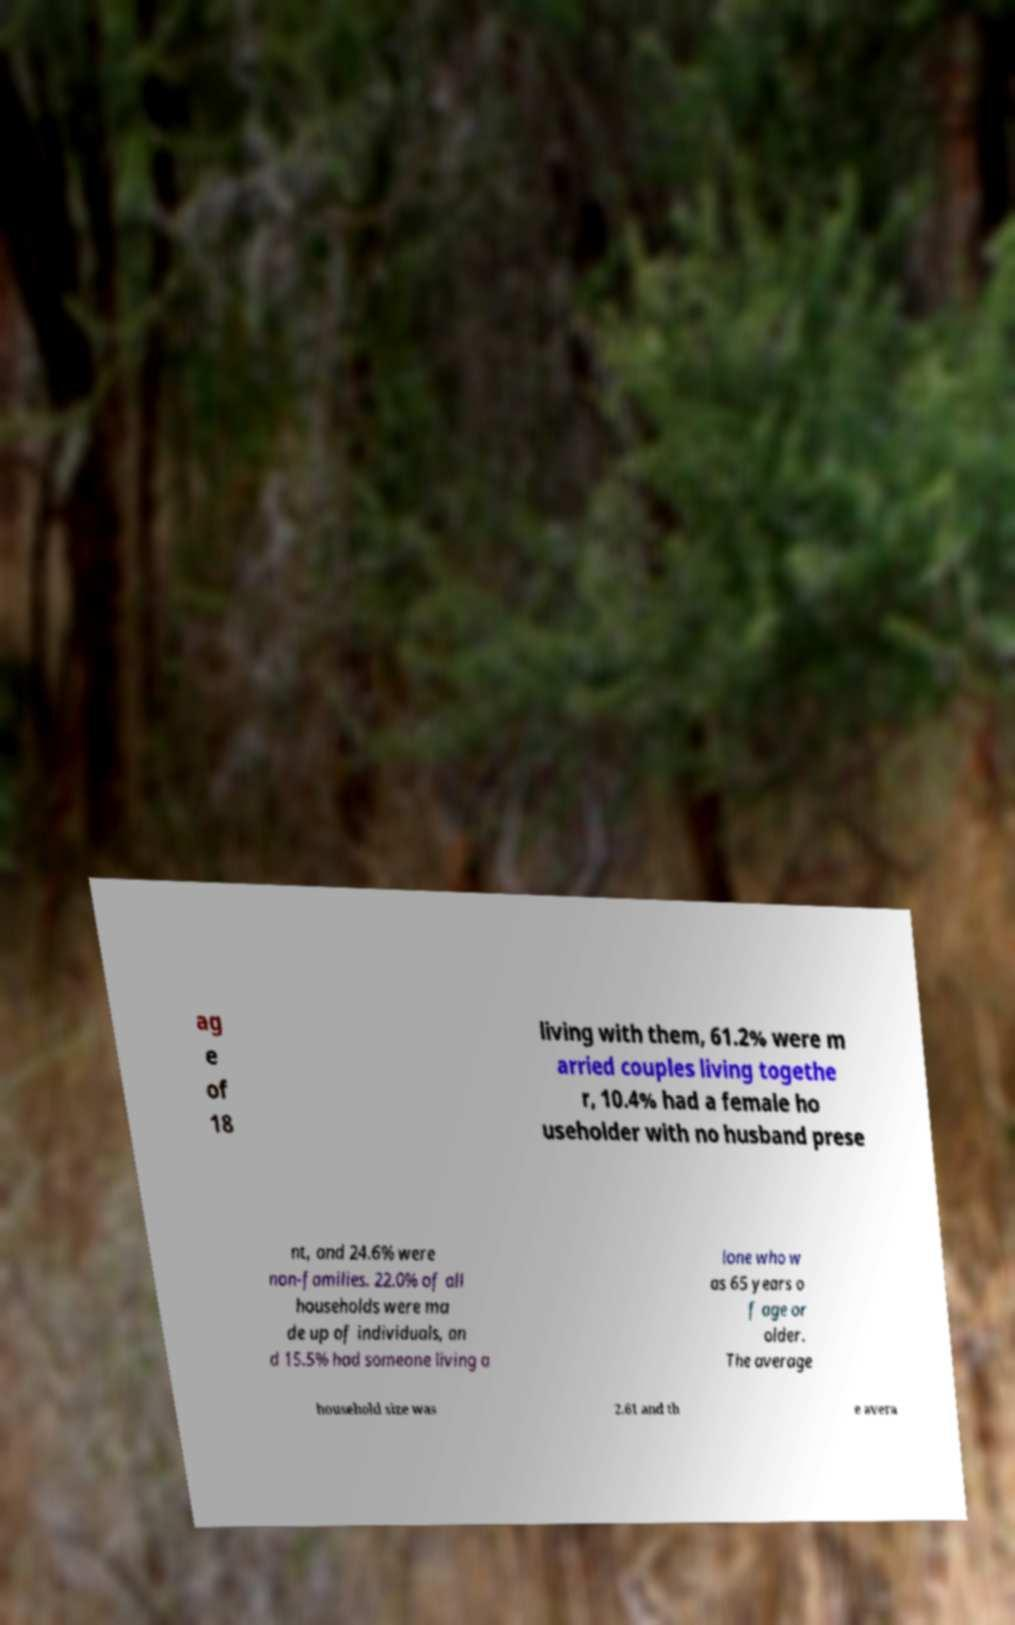Can you accurately transcribe the text from the provided image for me? ag e of 18 living with them, 61.2% were m arried couples living togethe r, 10.4% had a female ho useholder with no husband prese nt, and 24.6% were non-families. 22.0% of all households were ma de up of individuals, an d 15.5% had someone living a lone who w as 65 years o f age or older. The average household size was 2.61 and th e avera 